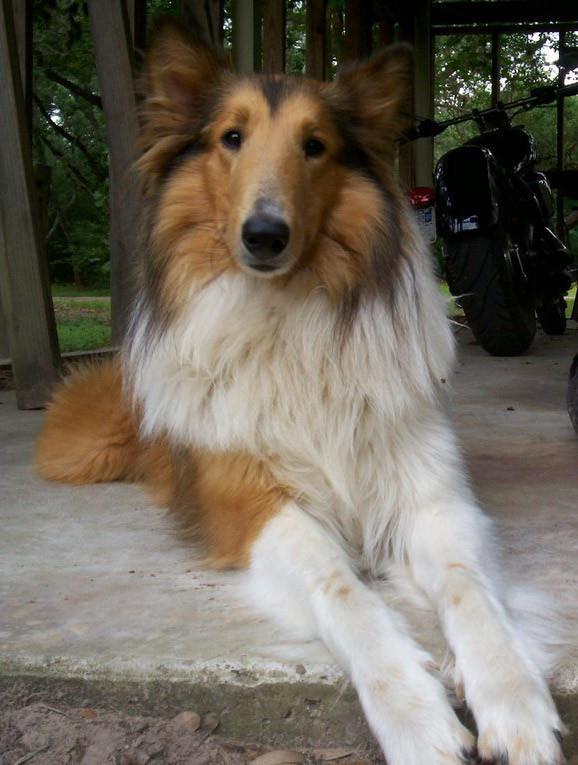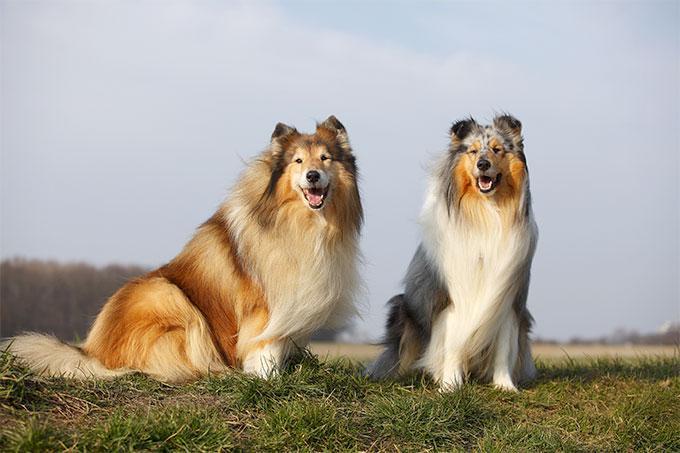The first image is the image on the left, the second image is the image on the right. Considering the images on both sides, is "the collie on the left image is sitting with its front legs straight up." valid? Answer yes or no. No. 